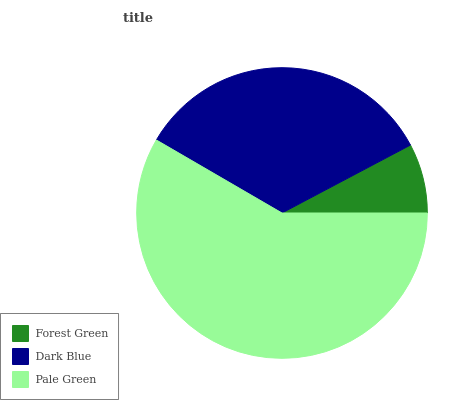Is Forest Green the minimum?
Answer yes or no. Yes. Is Pale Green the maximum?
Answer yes or no. Yes. Is Dark Blue the minimum?
Answer yes or no. No. Is Dark Blue the maximum?
Answer yes or no. No. Is Dark Blue greater than Forest Green?
Answer yes or no. Yes. Is Forest Green less than Dark Blue?
Answer yes or no. Yes. Is Forest Green greater than Dark Blue?
Answer yes or no. No. Is Dark Blue less than Forest Green?
Answer yes or no. No. Is Dark Blue the high median?
Answer yes or no. Yes. Is Dark Blue the low median?
Answer yes or no. Yes. Is Forest Green the high median?
Answer yes or no. No. Is Pale Green the low median?
Answer yes or no. No. 